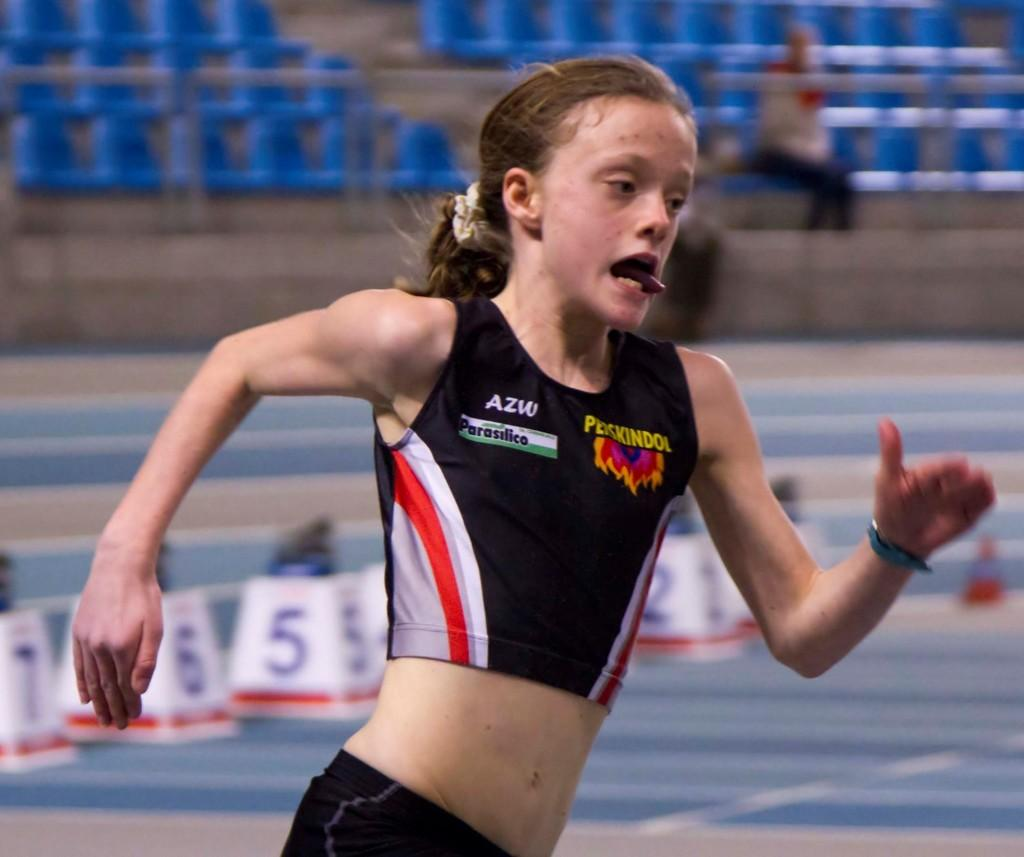<image>
Present a compact description of the photo's key features. The letters AZW are on the front of a tank top on a girl that is running. 